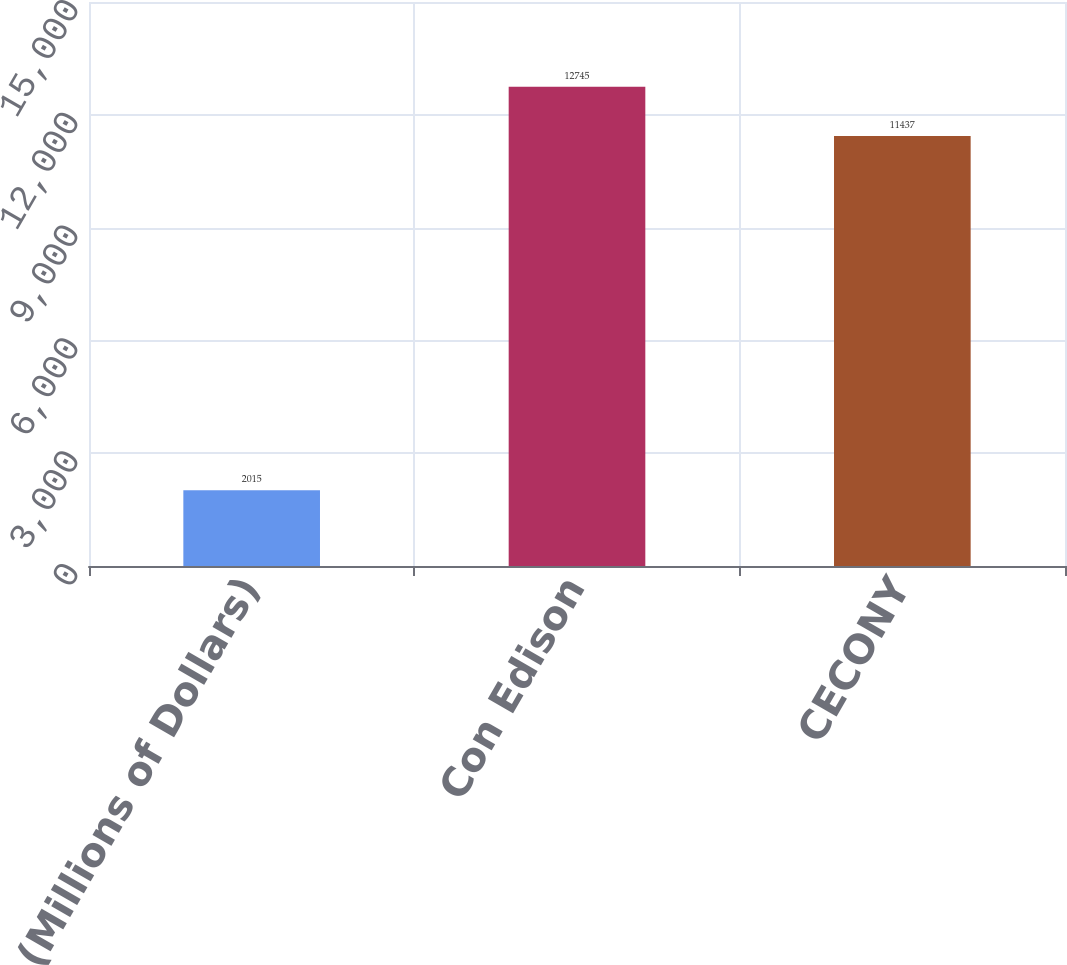Convert chart. <chart><loc_0><loc_0><loc_500><loc_500><bar_chart><fcel>(Millions of Dollars)<fcel>Con Edison<fcel>CECONY<nl><fcel>2015<fcel>12745<fcel>11437<nl></chart> 